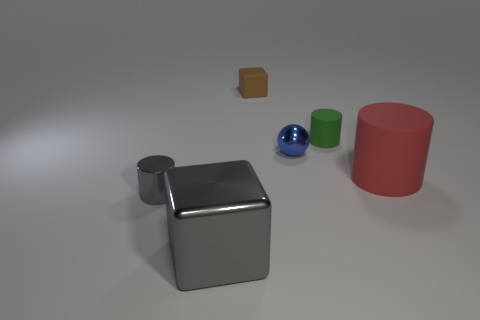What material is the large gray object? metal 